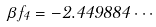<formula> <loc_0><loc_0><loc_500><loc_500>\beta f _ { 4 } = - 2 . 4 4 9 8 8 4 \cdots</formula> 